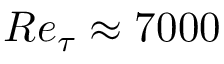<formula> <loc_0><loc_0><loc_500><loc_500>R e _ { \tau } \approx 7 0 0 0</formula> 